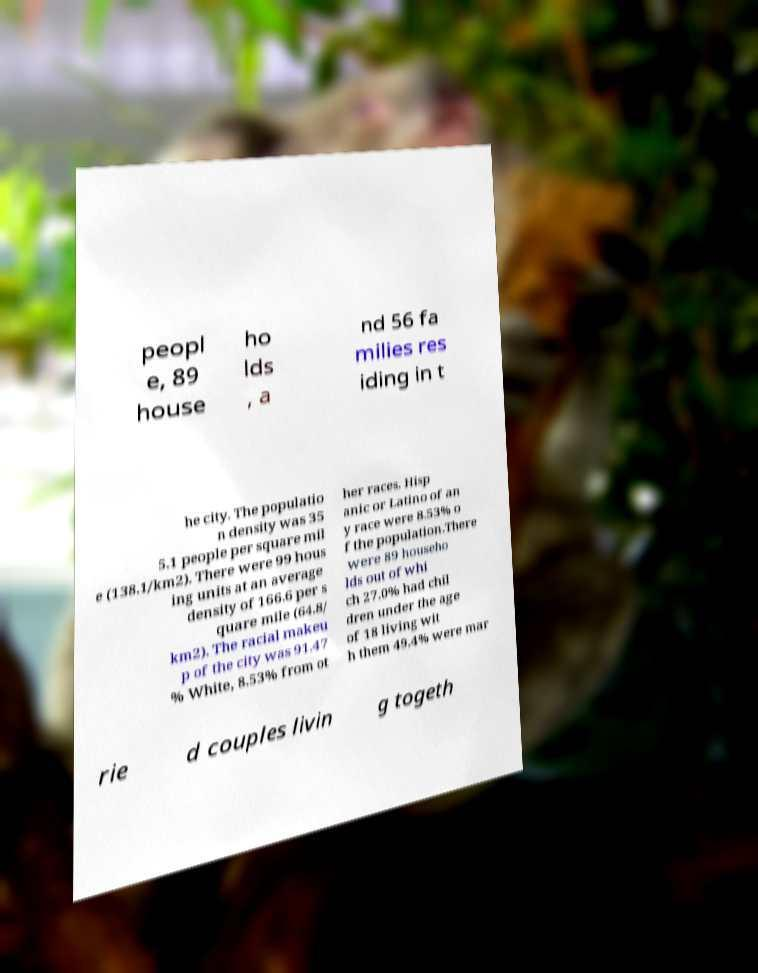Could you extract and type out the text from this image? peopl e, 89 house ho lds , a nd 56 fa milies res iding in t he city. The populatio n density was 35 5.1 people per square mil e (138.1/km2). There were 99 hous ing units at an average density of 166.6 per s quare mile (64.8/ km2). The racial makeu p of the city was 91.47 % White, 8.53% from ot her races. Hisp anic or Latino of an y race were 8.53% o f the population.There were 89 househo lds out of whi ch 27.0% had chil dren under the age of 18 living wit h them 49.4% were mar rie d couples livin g togeth 